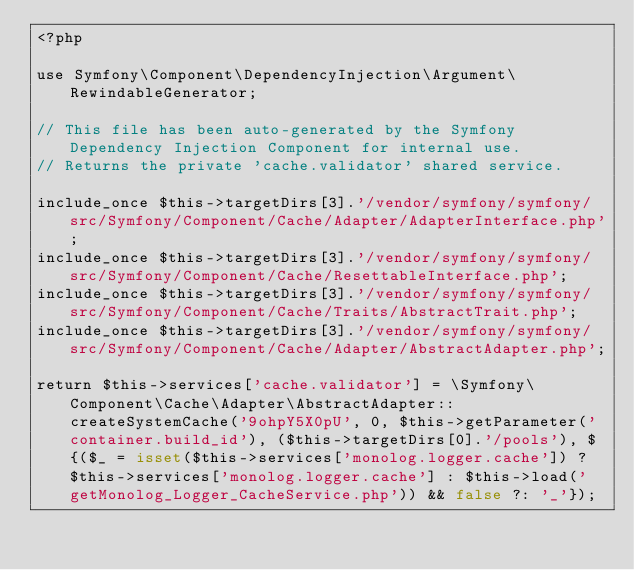Convert code to text. <code><loc_0><loc_0><loc_500><loc_500><_PHP_><?php

use Symfony\Component\DependencyInjection\Argument\RewindableGenerator;

// This file has been auto-generated by the Symfony Dependency Injection Component for internal use.
// Returns the private 'cache.validator' shared service.

include_once $this->targetDirs[3].'/vendor/symfony/symfony/src/Symfony/Component/Cache/Adapter/AdapterInterface.php';
include_once $this->targetDirs[3].'/vendor/symfony/symfony/src/Symfony/Component/Cache/ResettableInterface.php';
include_once $this->targetDirs[3].'/vendor/symfony/symfony/src/Symfony/Component/Cache/Traits/AbstractTrait.php';
include_once $this->targetDirs[3].'/vendor/symfony/symfony/src/Symfony/Component/Cache/Adapter/AbstractAdapter.php';

return $this->services['cache.validator'] = \Symfony\Component\Cache\Adapter\AbstractAdapter::createSystemCache('9ohpY5X0pU', 0, $this->getParameter('container.build_id'), ($this->targetDirs[0].'/pools'), ${($_ = isset($this->services['monolog.logger.cache']) ? $this->services['monolog.logger.cache'] : $this->load('getMonolog_Logger_CacheService.php')) && false ?: '_'});
</code> 